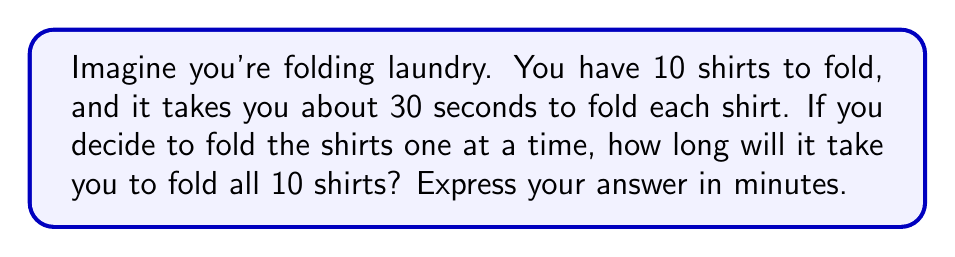Could you help me with this problem? Let's break this down step-by-step:

1. We know that:
   - There are 10 shirts to fold
   - It takes 30 seconds to fold each shirt

2. To find the total time, we need to multiply the number of shirts by the time it takes to fold one shirt:
   $$ \text{Total time} = \text{Number of shirts} \times \text{Time per shirt} $$
   $$ \text{Total time} = 10 \times 30 \text{ seconds} = 300 \text{ seconds} $$

3. Now, we need to convert seconds to minutes. We know that 1 minute = 60 seconds.
   To convert, we divide the total seconds by 60:
   $$ \text{Time in minutes} = \frac{\text{Total seconds}}{60} $$
   $$ \text{Time in minutes} = \frac{300}{60} = 5 \text{ minutes} $$

Therefore, it will take 5 minutes to fold all 10 shirts.
Answer: 5 minutes 